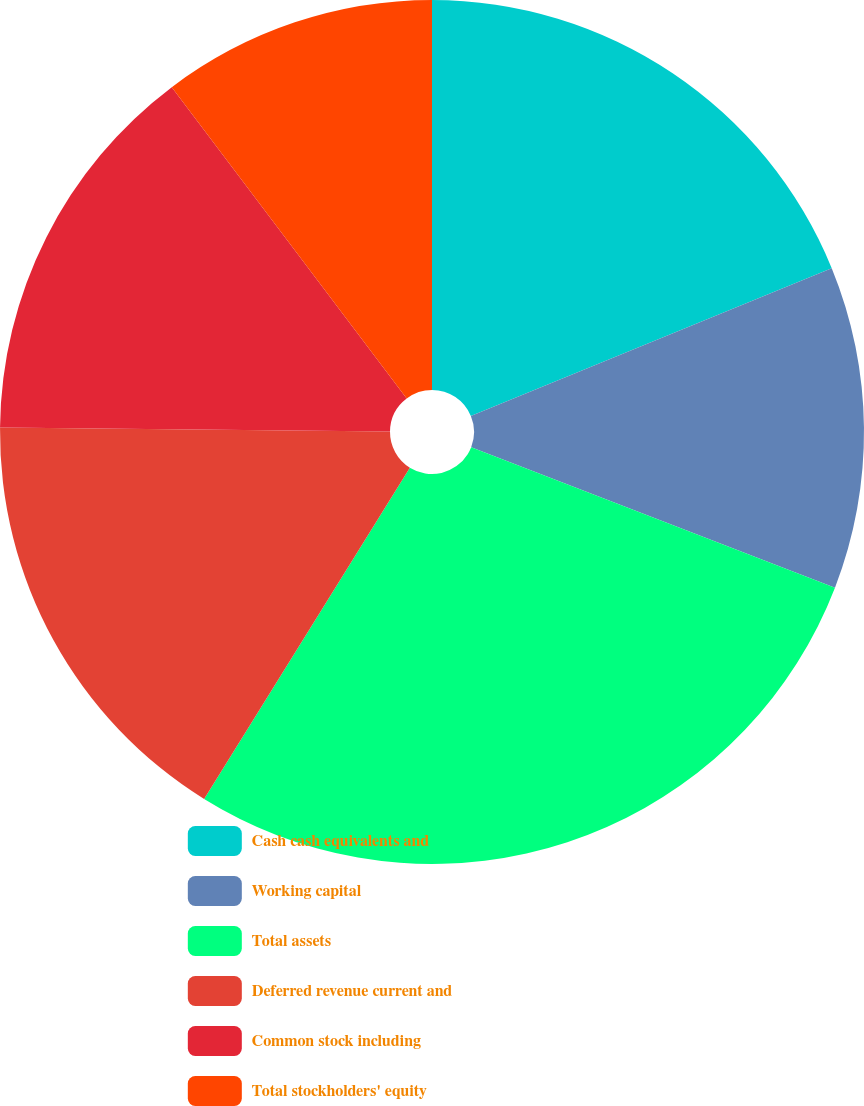<chart> <loc_0><loc_0><loc_500><loc_500><pie_chart><fcel>Cash cash equivalents and<fcel>Working capital<fcel>Total assets<fcel>Deferred revenue current and<fcel>Common stock including<fcel>Total stockholders' equity<nl><fcel>18.81%<fcel>12.06%<fcel>27.98%<fcel>16.32%<fcel>14.55%<fcel>10.29%<nl></chart> 